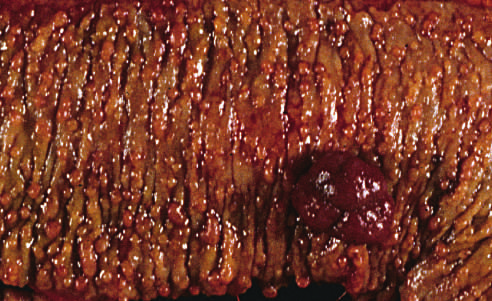re immature myeloid cells present along with a dominant polyp (right)?
Answer the question using a single word or phrase. No 